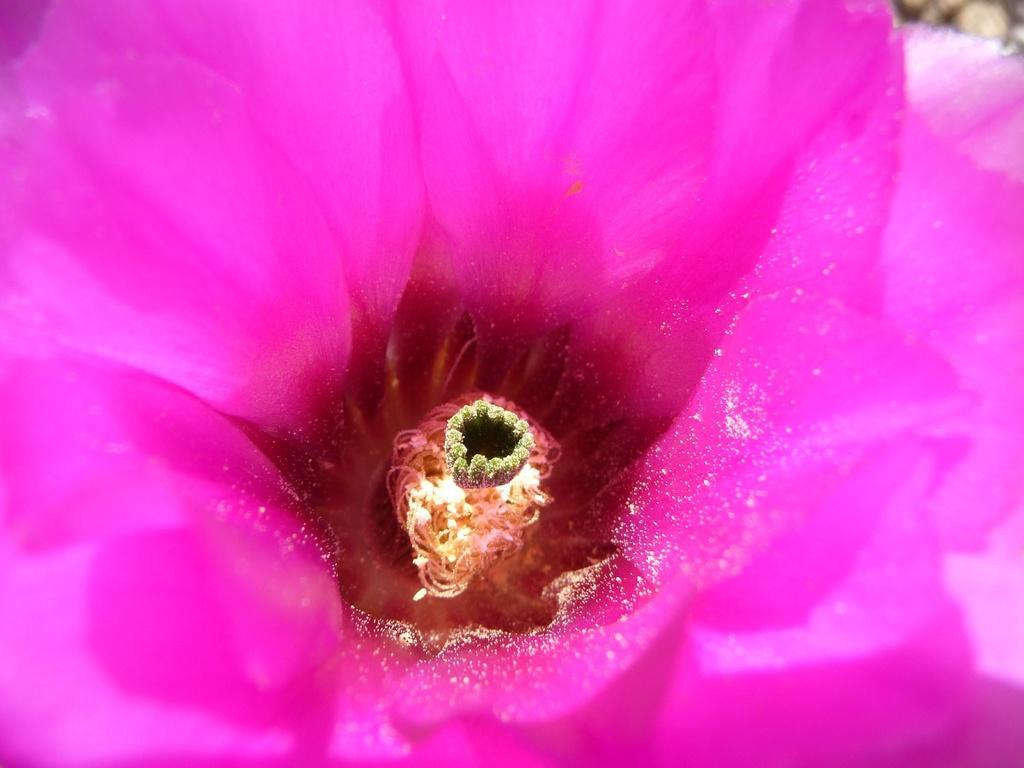In one or two sentences, can you explain what this image depicts? In this image I can see a pink color flower. The background is blurred. 